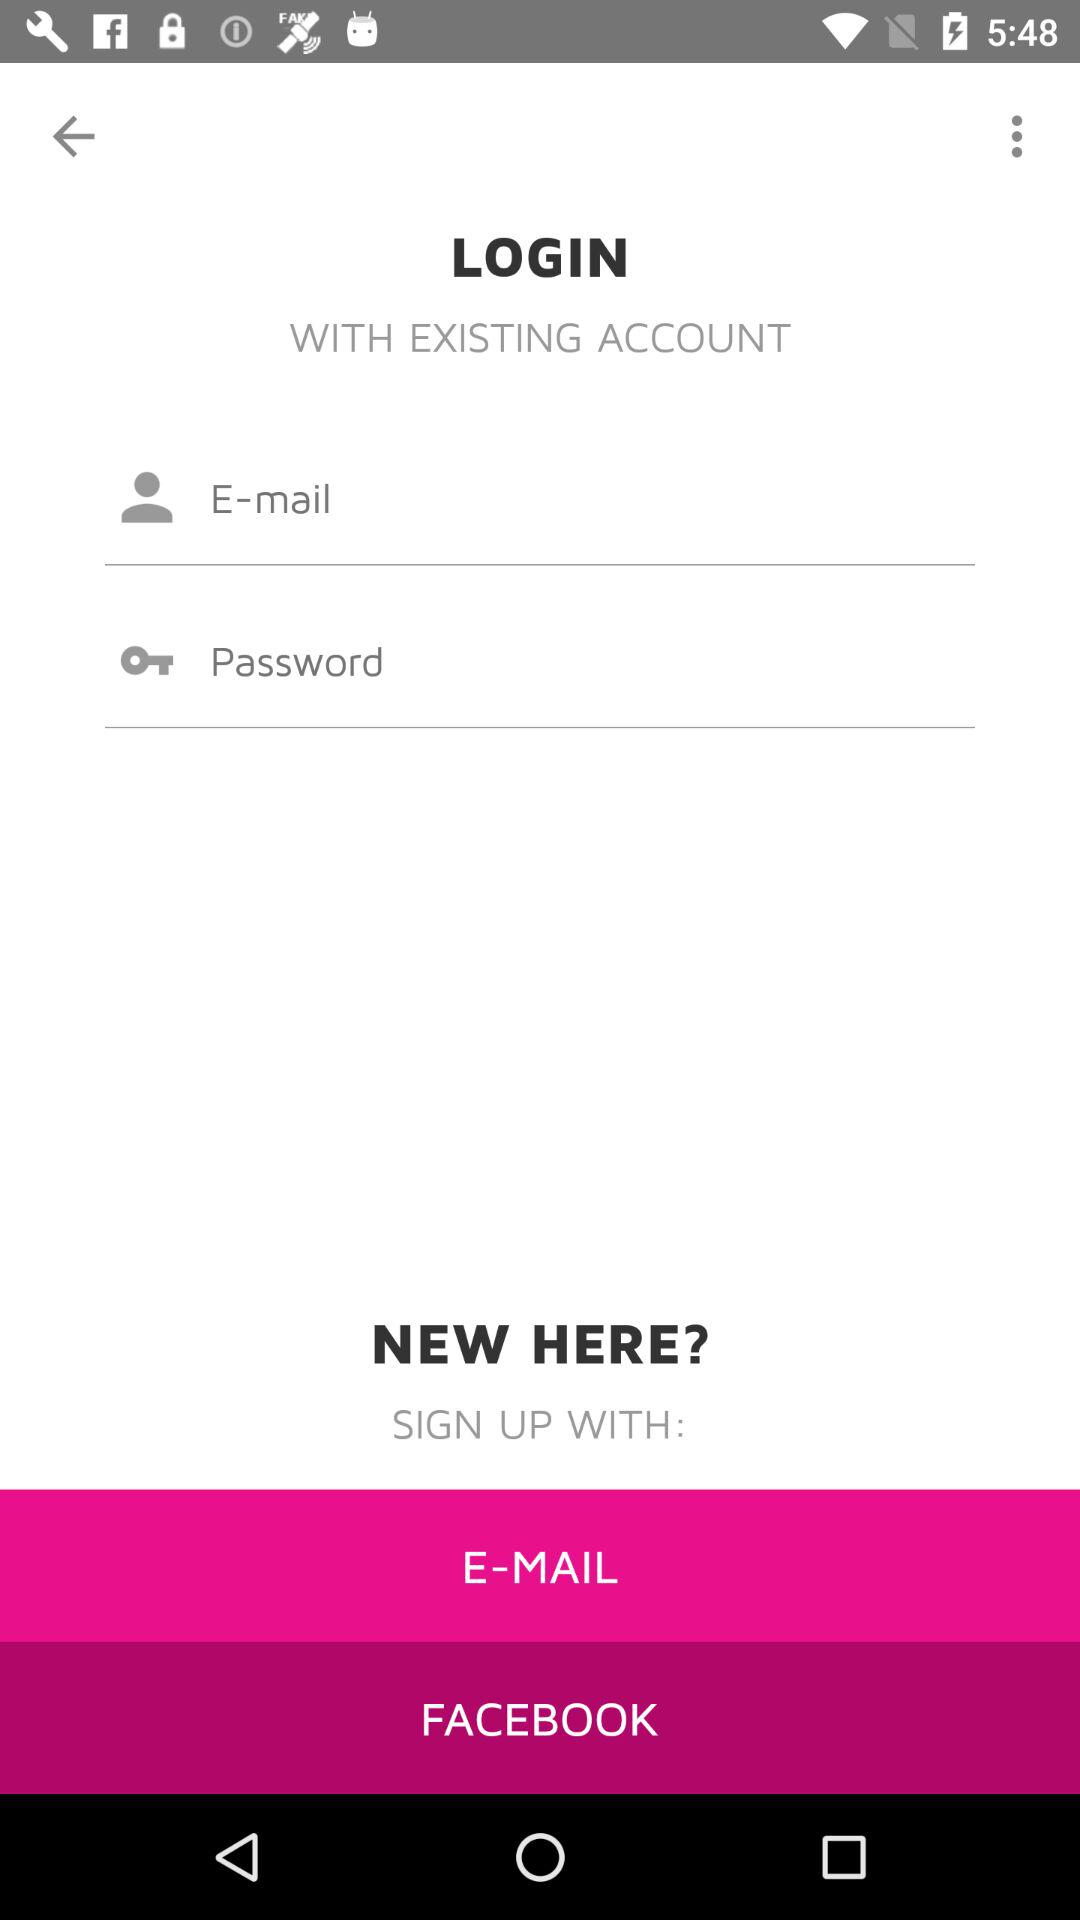Through which application can we sign up? You can sign up through "E-MAIL" and "FACEBOOK". 